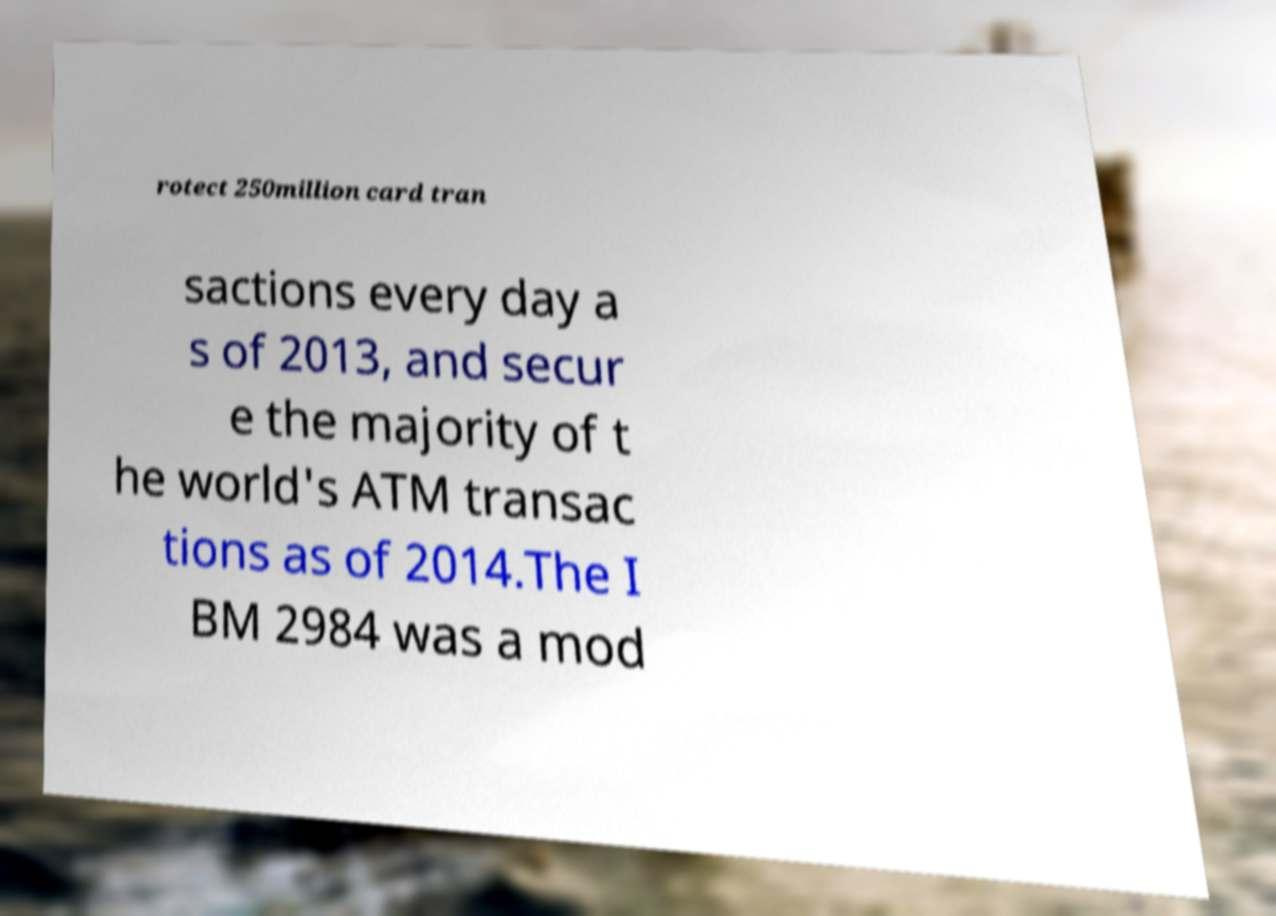Please identify and transcribe the text found in this image. rotect 250million card tran sactions every day a s of 2013, and secur e the majority of t he world's ATM transac tions as of 2014.The I BM 2984 was a mod 